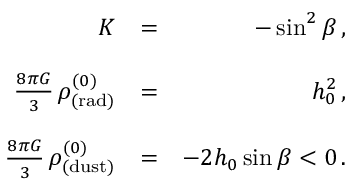<formula> <loc_0><loc_0><loc_500><loc_500>\begin{array} { r l r } { K } & { = } & { - \sin ^ { 2 } \beta \, , } \\ & \\ { \frac { 8 \pi G } { 3 } \, \rho _ { ( r a d ) } ^ { ( 0 ) } } & { = } & { h _ { 0 } ^ { 2 } \, , } \\ & \\ { \frac { 8 \pi G } { 3 } \, \rho _ { ( d u s t ) } ^ { ( 0 ) } } & { = } & { - 2 h _ { 0 } \sin \beta < 0 \, . } \end{array}</formula> 